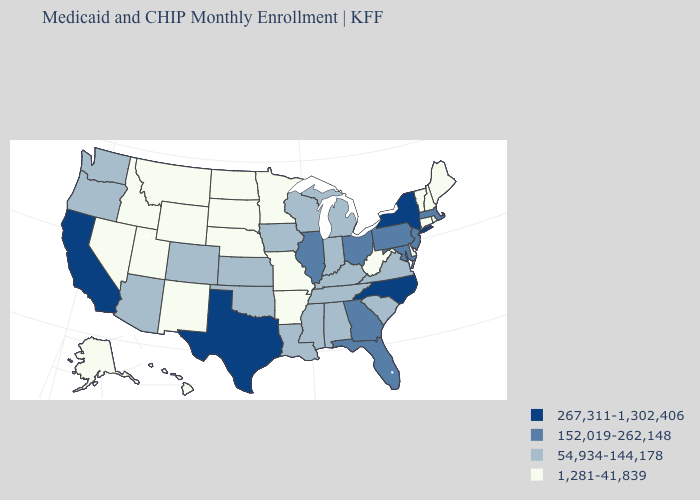What is the highest value in the USA?
Write a very short answer. 267,311-1,302,406. Name the states that have a value in the range 54,934-144,178?
Quick response, please. Alabama, Arizona, Colorado, Indiana, Iowa, Kansas, Kentucky, Louisiana, Michigan, Mississippi, Oklahoma, Oregon, South Carolina, Tennessee, Virginia, Washington, Wisconsin. Name the states that have a value in the range 54,934-144,178?
Answer briefly. Alabama, Arizona, Colorado, Indiana, Iowa, Kansas, Kentucky, Louisiana, Michigan, Mississippi, Oklahoma, Oregon, South Carolina, Tennessee, Virginia, Washington, Wisconsin. What is the lowest value in states that border Mississippi?
Quick response, please. 1,281-41,839. Name the states that have a value in the range 54,934-144,178?
Concise answer only. Alabama, Arizona, Colorado, Indiana, Iowa, Kansas, Kentucky, Louisiana, Michigan, Mississippi, Oklahoma, Oregon, South Carolina, Tennessee, Virginia, Washington, Wisconsin. Name the states that have a value in the range 152,019-262,148?
Give a very brief answer. Florida, Georgia, Illinois, Maryland, Massachusetts, New Jersey, Ohio, Pennsylvania. What is the value of Hawaii?
Be succinct. 1,281-41,839. What is the value of Alabama?
Short answer required. 54,934-144,178. Name the states that have a value in the range 267,311-1,302,406?
Short answer required. California, New York, North Carolina, Texas. What is the value of Rhode Island?
Answer briefly. 1,281-41,839. What is the highest value in the USA?
Concise answer only. 267,311-1,302,406. What is the value of Massachusetts?
Keep it brief. 152,019-262,148. Name the states that have a value in the range 1,281-41,839?
Keep it brief. Alaska, Arkansas, Connecticut, Delaware, Hawaii, Idaho, Maine, Minnesota, Missouri, Montana, Nebraska, Nevada, New Hampshire, New Mexico, North Dakota, Rhode Island, South Dakota, Utah, Vermont, West Virginia, Wyoming. Does Illinois have the highest value in the MidWest?
Concise answer only. Yes. Among the states that border Vermont , does New Hampshire have the lowest value?
Give a very brief answer. Yes. 